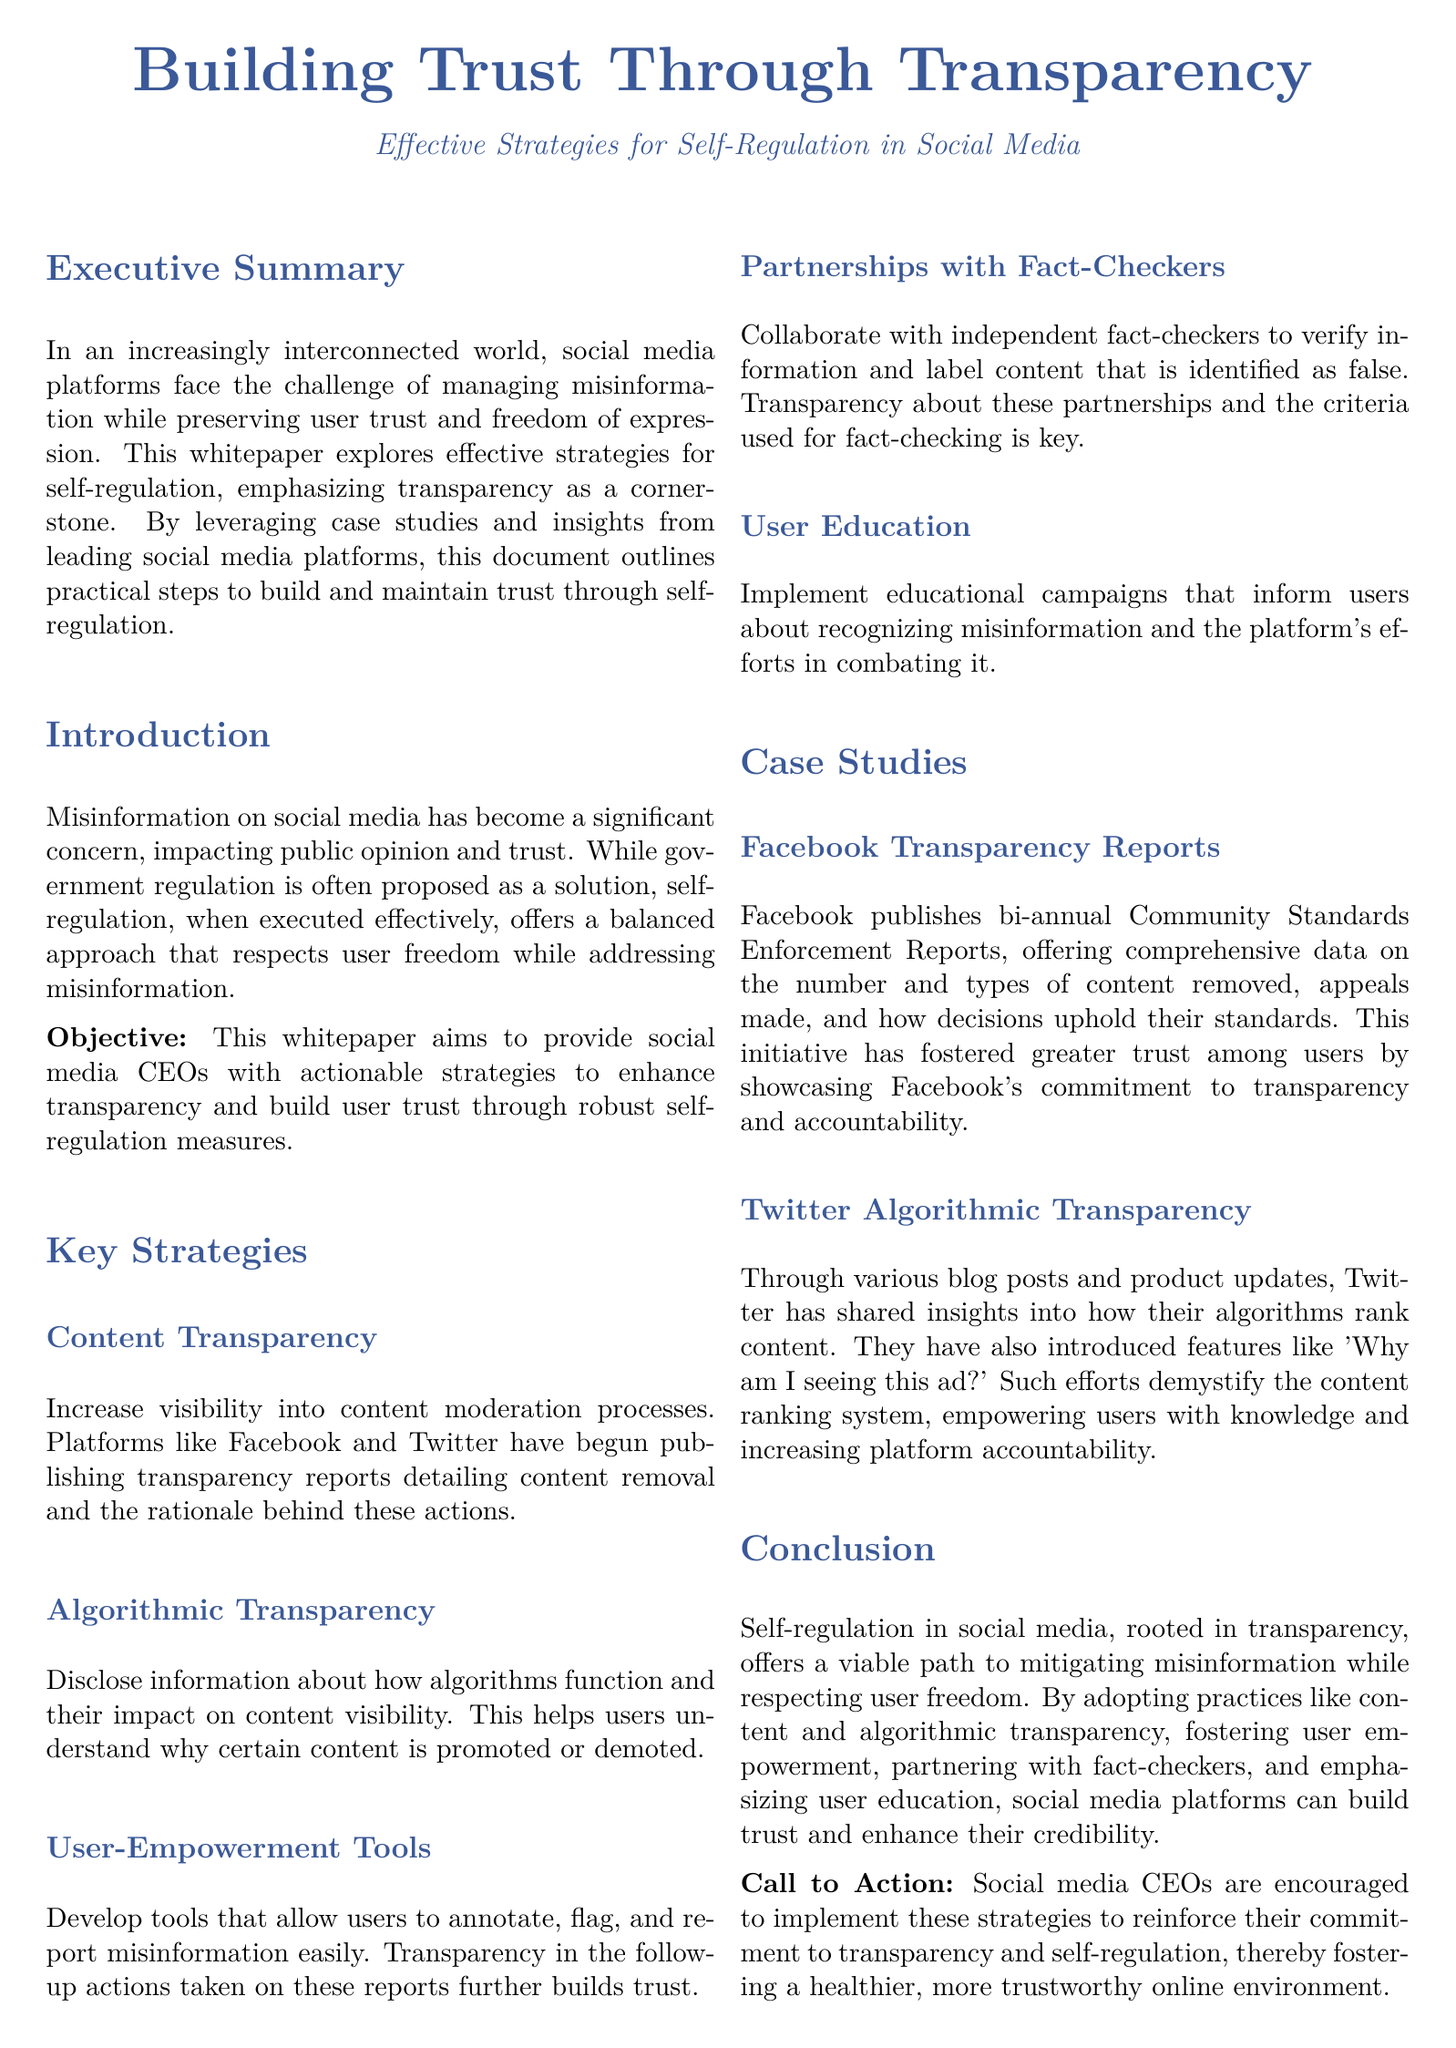What is the focus of the whitepaper? The whitepaper focuses on building trust through transparency and effective self-regulation strategies in social media.
Answer: Building trust through transparency What is one key strategy for self-regulation mentioned? One key strategy highlighted for self-regulation is content transparency.
Answer: Content transparency How often does Facebook publish transparency reports? Facebook publishes transparency reports bi-annually.
Answer: Bi-annually What type of collaboration is suggested to improve misinformation handling? Collaborating with independent fact-checkers is suggested.
Answer: Independent fact-checkers What is the role of user education in the proposed strategies? User education helps inform users about recognizing misinformation and the platform's efforts.
Answer: Inform users about recognizing misinformation What results did Facebook achieve through its transparency reports? Facebook fostered greater trust among users through transparency reports.
Answer: Greater trust How does Twitter promote algorithmic transparency? Twitter promotes algorithmic transparency through blog posts and product updates.
Answer: Blog posts and product updates What is the objective of the whitepaper? The objective is to provide actionable strategies to enhance transparency.
Answer: Actionable strategies to enhance transparency 